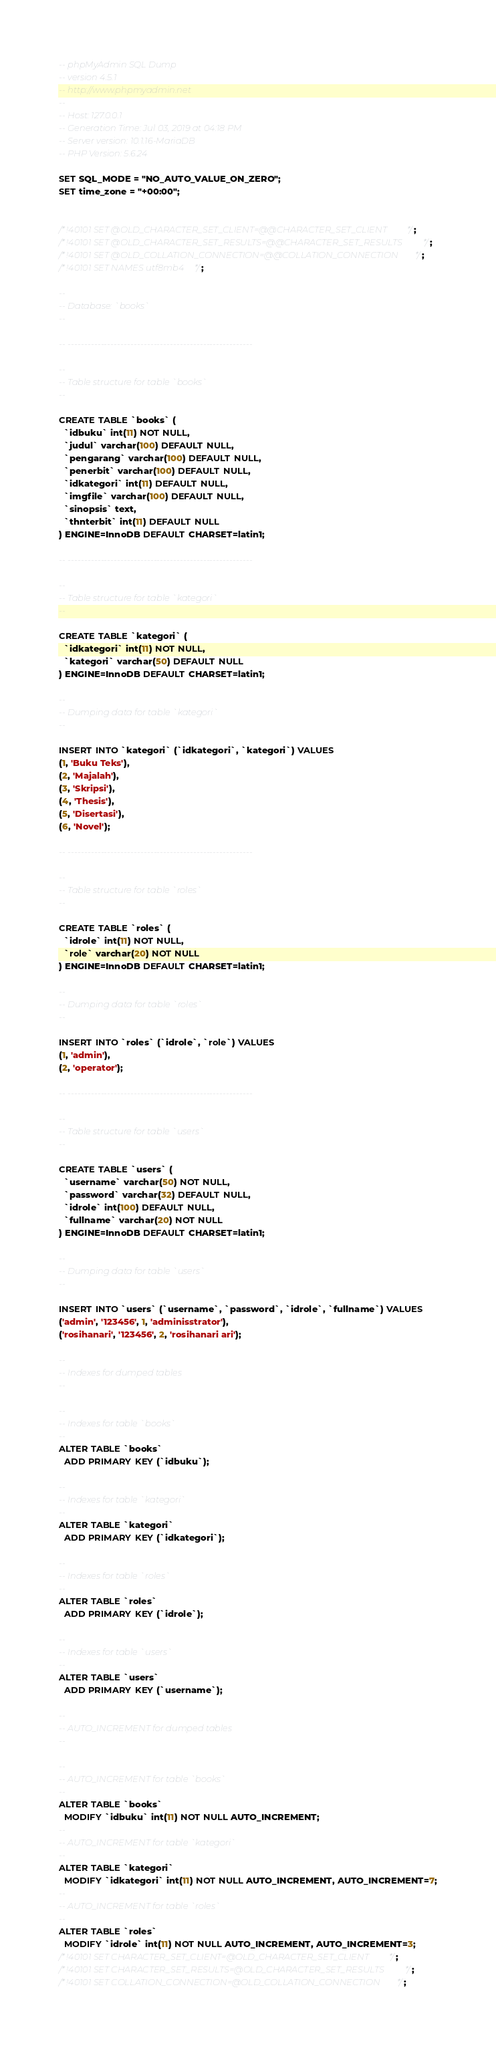Convert code to text. <code><loc_0><loc_0><loc_500><loc_500><_SQL_>-- phpMyAdmin SQL Dump
-- version 4.5.1
-- http://www.phpmyadmin.net
--
-- Host: 127.0.0.1
-- Generation Time: Jul 03, 2019 at 04:18 PM
-- Server version: 10.1.16-MariaDB
-- PHP Version: 5.6.24

SET SQL_MODE = "NO_AUTO_VALUE_ON_ZERO";
SET time_zone = "+00:00";


/*!40101 SET @OLD_CHARACTER_SET_CLIENT=@@CHARACTER_SET_CLIENT */;
/*!40101 SET @OLD_CHARACTER_SET_RESULTS=@@CHARACTER_SET_RESULTS */;
/*!40101 SET @OLD_COLLATION_CONNECTION=@@COLLATION_CONNECTION */;
/*!40101 SET NAMES utf8mb4 */;

--
-- Database: `books`
--

-- --------------------------------------------------------

--
-- Table structure for table `books`
--

CREATE TABLE `books` (
  `idbuku` int(11) NOT NULL,
  `judul` varchar(100) DEFAULT NULL,
  `pengarang` varchar(100) DEFAULT NULL,
  `penerbit` varchar(100) DEFAULT NULL,
  `idkategori` int(11) DEFAULT NULL,
  `imgfile` varchar(100) DEFAULT NULL,
  `sinopsis` text,
  `thnterbit` int(11) DEFAULT NULL
) ENGINE=InnoDB DEFAULT CHARSET=latin1;

-- --------------------------------------------------------

--
-- Table structure for table `kategori`
--

CREATE TABLE `kategori` (
  `idkategori` int(11) NOT NULL,
  `kategori` varchar(50) DEFAULT NULL
) ENGINE=InnoDB DEFAULT CHARSET=latin1;

--
-- Dumping data for table `kategori`
--

INSERT INTO `kategori` (`idkategori`, `kategori`) VALUES
(1, 'Buku Teks'),
(2, 'Majalah'),
(3, 'Skripsi'),
(4, 'Thesis'),
(5, 'Disertasi'),
(6, 'Novel');

-- --------------------------------------------------------

--
-- Table structure for table `roles`
--

CREATE TABLE `roles` (
  `idrole` int(11) NOT NULL,
  `role` varchar(20) NOT NULL
) ENGINE=InnoDB DEFAULT CHARSET=latin1;

--
-- Dumping data for table `roles`
--

INSERT INTO `roles` (`idrole`, `role`) VALUES
(1, 'admin'),
(2, 'operator');

-- --------------------------------------------------------

--
-- Table structure for table `users`
--

CREATE TABLE `users` (
  `username` varchar(50) NOT NULL,
  `password` varchar(32) DEFAULT NULL,
  `idrole` int(100) DEFAULT NULL,
  `fullname` varchar(20) NOT NULL
) ENGINE=InnoDB DEFAULT CHARSET=latin1;

--
-- Dumping data for table `users`
--

INSERT INTO `users` (`username`, `password`, `idrole`, `fullname`) VALUES
('admin', '123456', 1, 'adminisstrator'),
('rosihanari', '123456', 2, 'rosihanari ari');

--
-- Indexes for dumped tables
--

--
-- Indexes for table `books`
--
ALTER TABLE `books`
  ADD PRIMARY KEY (`idbuku`);

--
-- Indexes for table `kategori`
--
ALTER TABLE `kategori`
  ADD PRIMARY KEY (`idkategori`);

--
-- Indexes for table `roles`
--
ALTER TABLE `roles`
  ADD PRIMARY KEY (`idrole`);

--
-- Indexes for table `users`
--
ALTER TABLE `users`
  ADD PRIMARY KEY (`username`);

--
-- AUTO_INCREMENT for dumped tables
--

--
-- AUTO_INCREMENT for table `books`
--
ALTER TABLE `books`
  MODIFY `idbuku` int(11) NOT NULL AUTO_INCREMENT;
--
-- AUTO_INCREMENT for table `kategori`
--
ALTER TABLE `kategori`
  MODIFY `idkategori` int(11) NOT NULL AUTO_INCREMENT, AUTO_INCREMENT=7;
--
-- AUTO_INCREMENT for table `roles`
--
ALTER TABLE `roles`
  MODIFY `idrole` int(11) NOT NULL AUTO_INCREMENT, AUTO_INCREMENT=3;
/*!40101 SET CHARACTER_SET_CLIENT=@OLD_CHARACTER_SET_CLIENT */;
/*!40101 SET CHARACTER_SET_RESULTS=@OLD_CHARACTER_SET_RESULTS */;
/*!40101 SET COLLATION_CONNECTION=@OLD_COLLATION_CONNECTION */;
</code> 